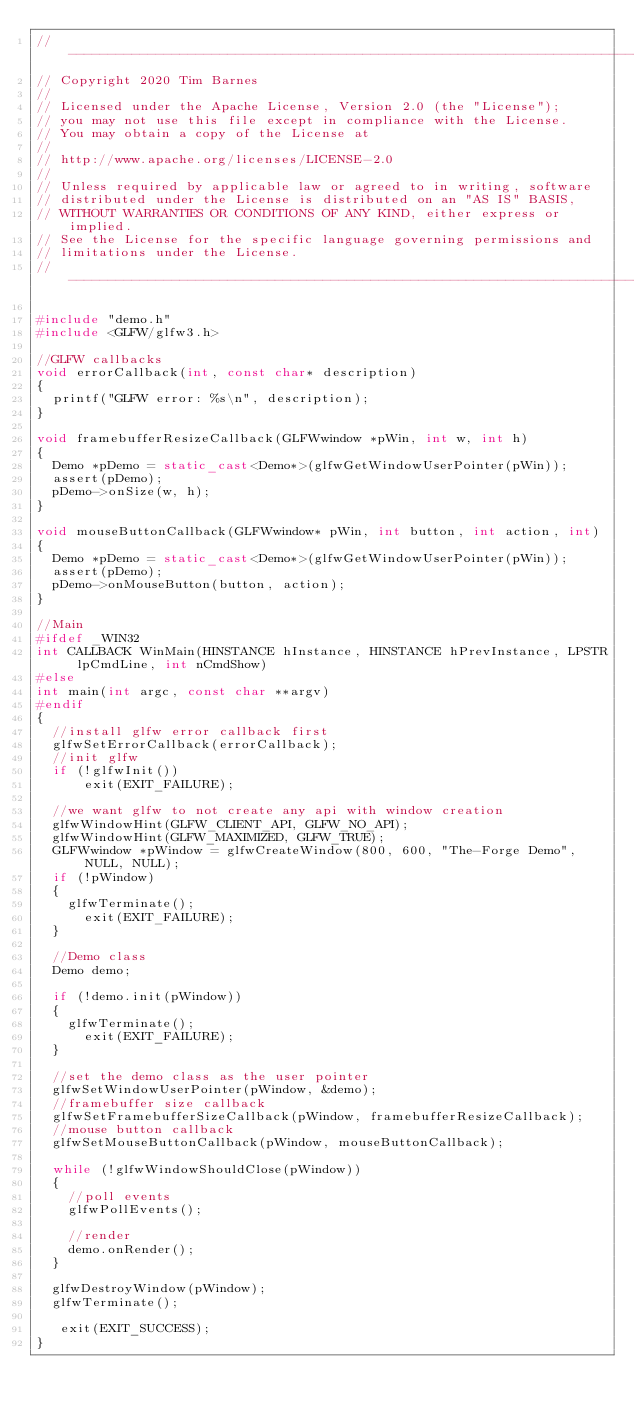<code> <loc_0><loc_0><loc_500><loc_500><_C++_>//-----------------------------------------------------------------------------
// Copyright 2020 Tim Barnes
//
// Licensed under the Apache License, Version 2.0 (the "License");
// you may not use this file except in compliance with the License.
// You may obtain a copy of the License at
//
// http://www.apache.org/licenses/LICENSE-2.0
//
// Unless required by applicable law or agreed to in writing, software
// distributed under the License is distributed on an "AS IS" BASIS,
// WITHOUT WARRANTIES OR CONDITIONS OF ANY KIND, either express or implied.
// See the License for the specific language governing permissions and
// limitations under the License.
//----------------------------------------------------------------------------

#include "demo.h"
#include <GLFW/glfw3.h>

//GLFW callbacks
void errorCallback(int, const char* description)
{
	printf("GLFW error: %s\n", description);
}

void framebufferResizeCallback(GLFWwindow *pWin, int w, int h)
{
	Demo *pDemo = static_cast<Demo*>(glfwGetWindowUserPointer(pWin));
	assert(pDemo);
	pDemo->onSize(w, h);
}

void mouseButtonCallback(GLFWwindow* pWin, int button, int action, int)
{
	Demo *pDemo = static_cast<Demo*>(glfwGetWindowUserPointer(pWin));
	assert(pDemo);
	pDemo->onMouseButton(button, action);
}

//Main
#ifdef _WIN32
int CALLBACK WinMain(HINSTANCE hInstance, HINSTANCE hPrevInstance, LPSTR lpCmdLine, int nCmdShow)
#else
int main(int argc, const char **argv)
#endif
{
	//install glfw error callback first
	glfwSetErrorCallback(errorCallback);
	//init glfw
	if (!glfwInit())
      exit(EXIT_FAILURE);

	//we want glfw to not create any api with window creation
	glfwWindowHint(GLFW_CLIENT_API, GLFW_NO_API);
	glfwWindowHint(GLFW_MAXIMIZED, GLFW_TRUE);
	GLFWwindow *pWindow = glfwCreateWindow(800, 600, "The-Forge Demo", NULL, NULL);
	if (!pWindow)
	{
		glfwTerminate();
      exit(EXIT_FAILURE);
	}

	//Demo class
	Demo demo;

	if (!demo.init(pWindow))
	{
		glfwTerminate();
      exit(EXIT_FAILURE);
	}

	//set the demo class as the user pointer
	glfwSetWindowUserPointer(pWindow, &demo);
	//framebuffer size callback
	glfwSetFramebufferSizeCallback(pWindow, framebufferResizeCallback);
	//mouse button callback
	glfwSetMouseButtonCallback(pWindow, mouseButtonCallback);

	while (!glfwWindowShouldClose(pWindow))
	{
		//poll events
		glfwPollEvents();

		//render
		demo.onRender();
	}

	glfwDestroyWindow(pWindow);
	glfwTerminate();
	
   exit(EXIT_SUCCESS);
} 
</code> 